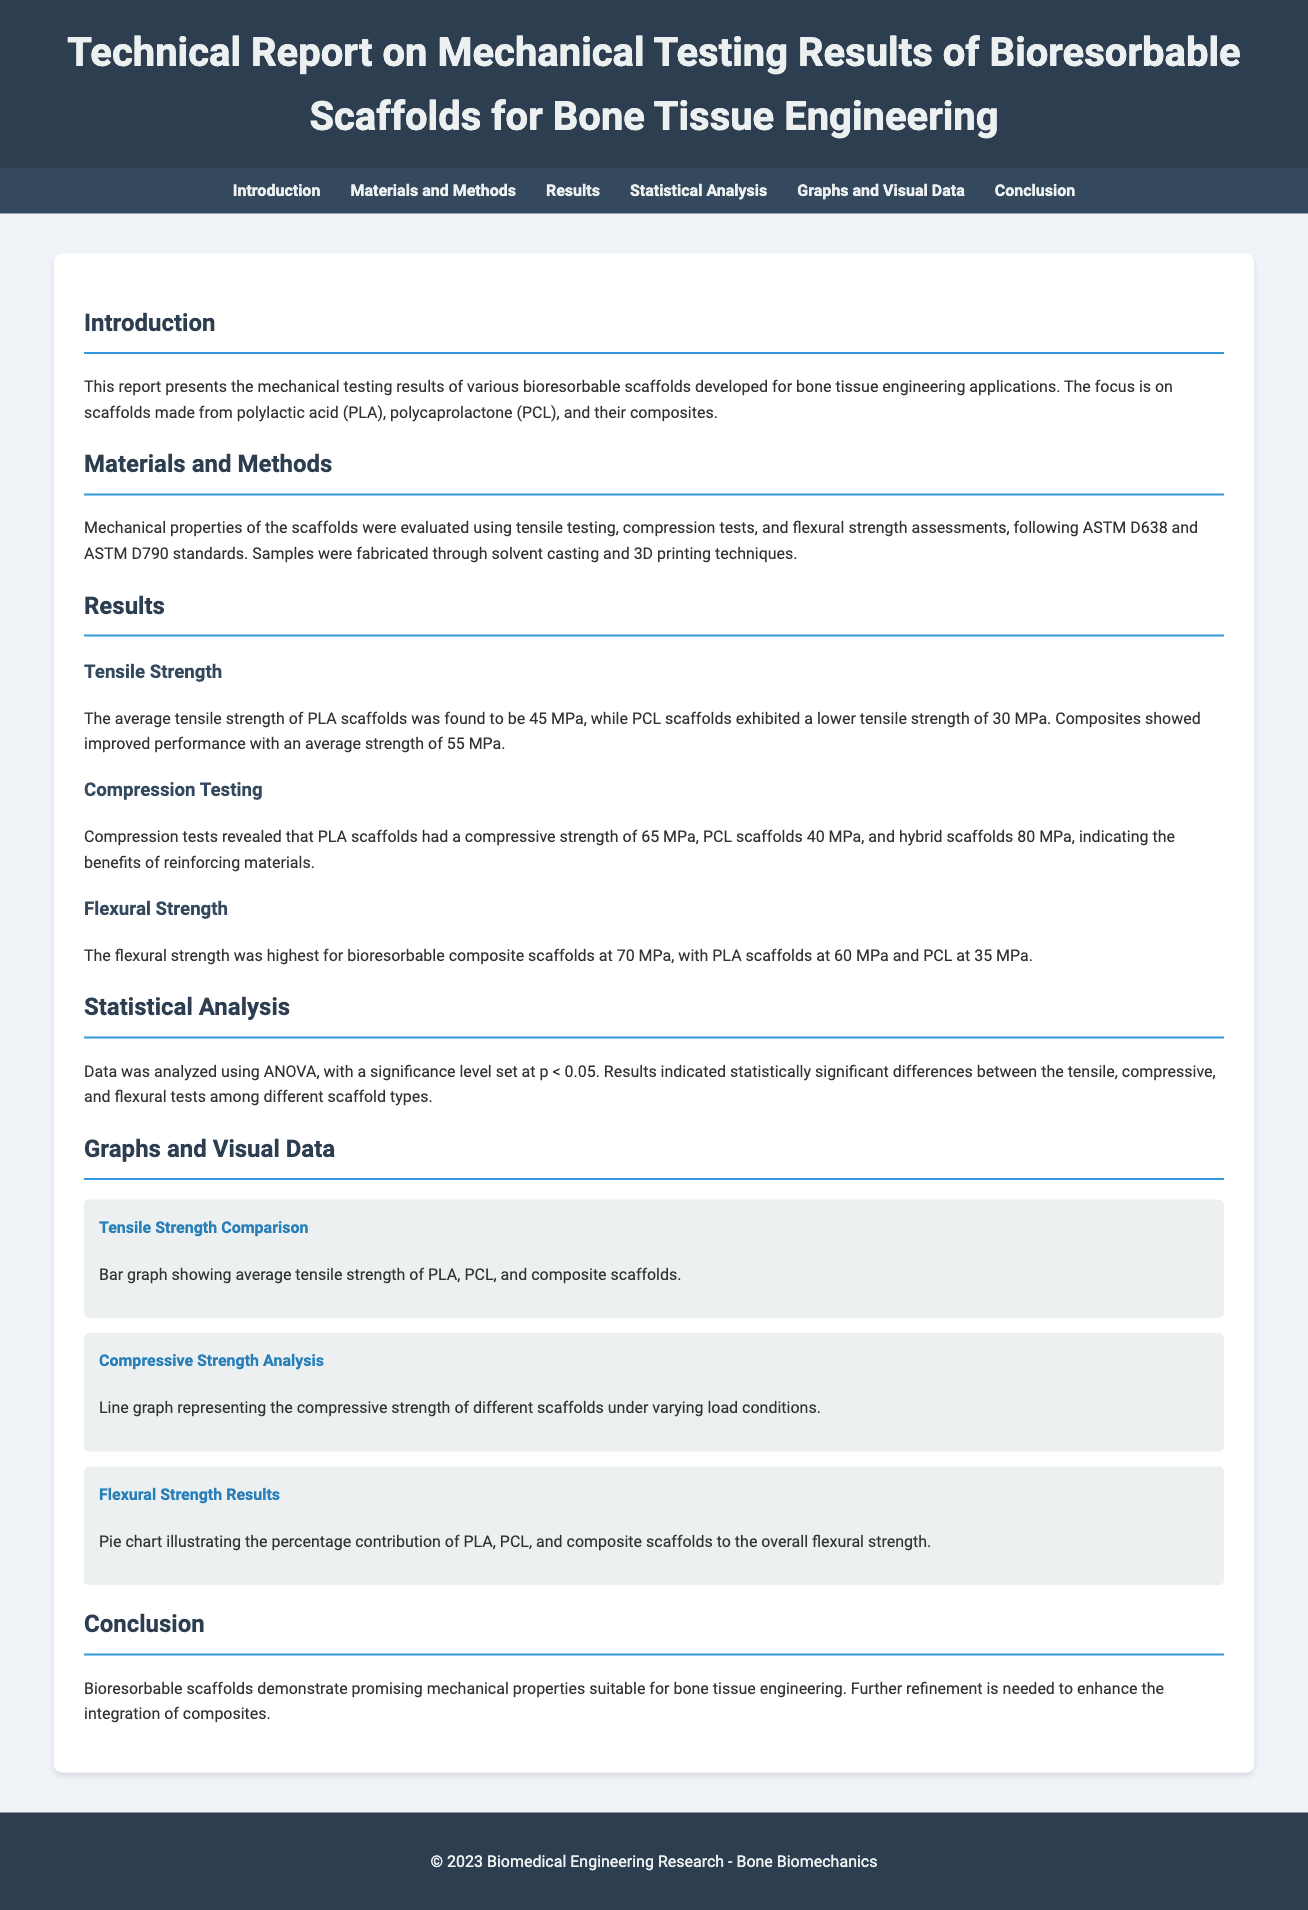What is the average tensile strength of PLA scaffolds? The report states that the average tensile strength of PLA scaffolds was found to be 45 MPa.
Answer: 45 MPa What material showed the highest compressive strength? According to the results, hybrid scaffolds had a compressive strength of 80 MPa, which is the highest among the materials tested.
Answer: Hybrid scaffolds What testing standard was followed for tensile testing? The document mentions that tensile testing was conducted following ASTM D638 standards.
Answer: ASTM D638 What was the statistical significance level used in the analysis? The significance level for the statistical analysis was set at p < 0.05 as stated in the statistical analysis section.
Answer: p < 0.05 Which scaffold type had the lowest flexural strength? The results indicate that PCL scaffolds had the lowest flexural strength at 35 MPa.
Answer: PCL scaffolds What was the focus of the study? The focus of the study is on bioresorbable scaffolds developed for bone tissue engineering applications.
Answer: Bioresorbable scaffolds What type of graph illustrates the percentage contribution of different materials to flexural strength? The document describes a pie chart to illustrate the percentage contribution of PLA, PCL, and composite scaffolds to the overall flexural strength.
Answer: Pie chart What indicates the need for further refinement in scaffolds? The conclusion states that further refinement is needed to enhance the integration of composites in the bioresorbable scaffolds.
Answer: Further refinement What is the title of the document? The title given in the header is "Technical Report on Mechanical Testing Results of Bioresorbable Scaffolds for Bone Tissue Engineering".
Answer: Technical Report on Mechanical Testing Results of Bioresorbable Scaffolds for Bone Tissue Engineering 